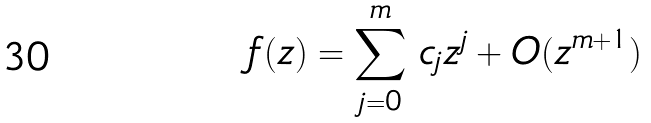Convert formula to latex. <formula><loc_0><loc_0><loc_500><loc_500>f ( z ) = \sum _ { j = 0 } ^ { m } \, c _ { j } z ^ { j } + O ( z ^ { m + 1 } )</formula> 